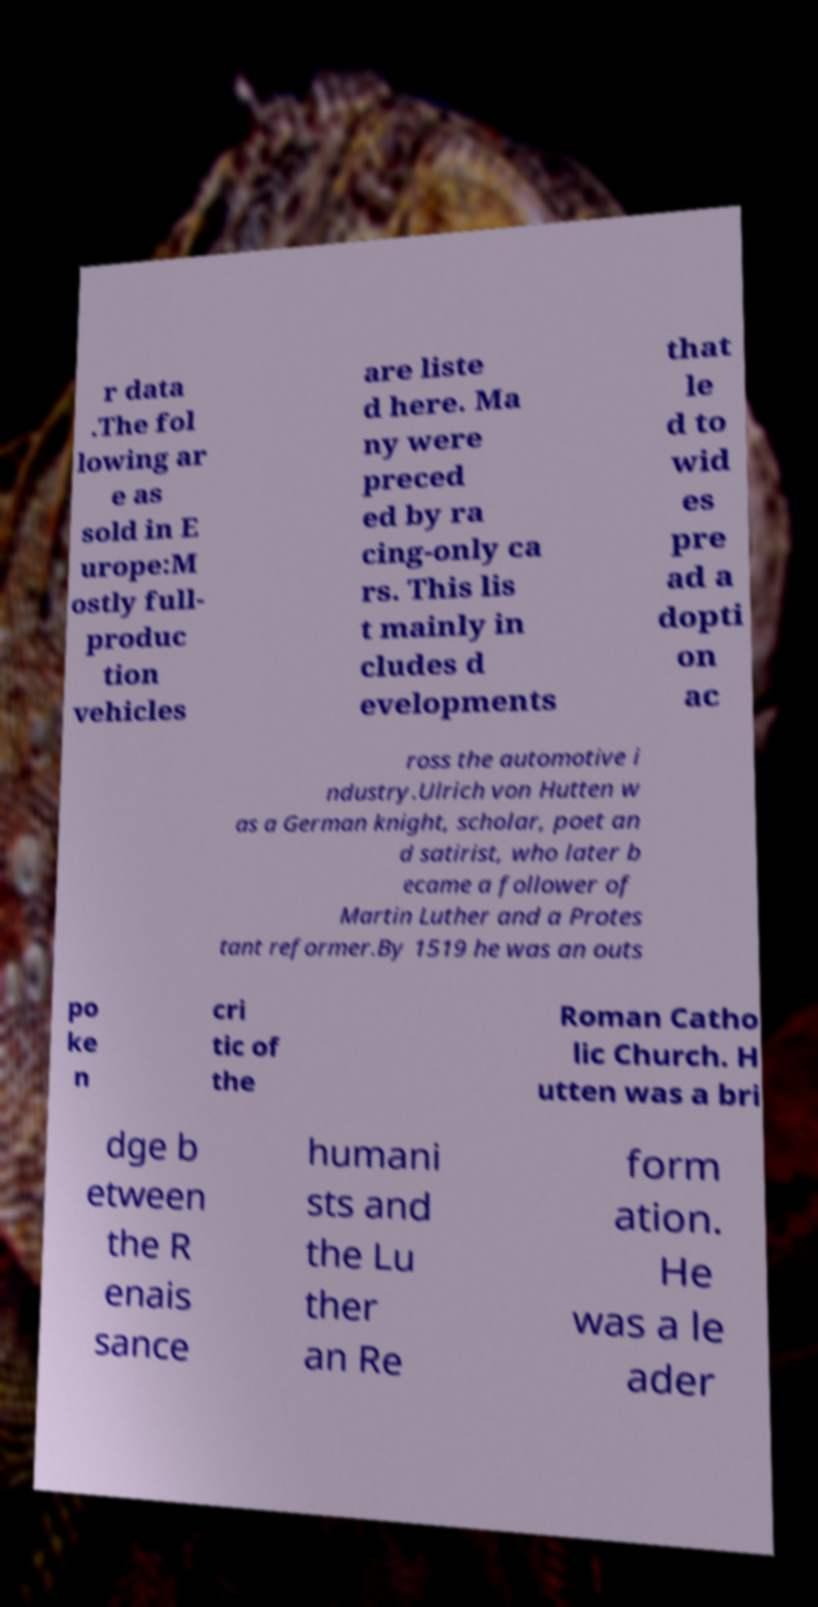Can you accurately transcribe the text from the provided image for me? r data .The fol lowing ar e as sold in E urope:M ostly full- produc tion vehicles are liste d here. Ma ny were preced ed by ra cing-only ca rs. This lis t mainly in cludes d evelopments that le d to wid es pre ad a dopti on ac ross the automotive i ndustry.Ulrich von Hutten w as a German knight, scholar, poet an d satirist, who later b ecame a follower of Martin Luther and a Protes tant reformer.By 1519 he was an outs po ke n cri tic of the Roman Catho lic Church. H utten was a bri dge b etween the R enais sance humani sts and the Lu ther an Re form ation. He was a le ader 